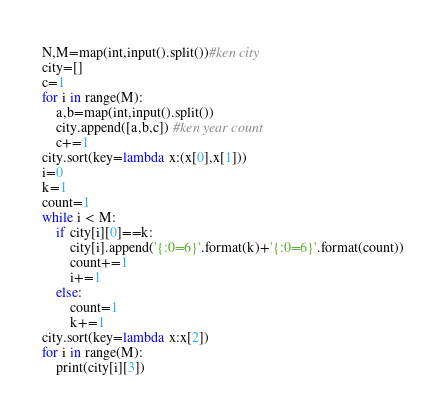Convert code to text. <code><loc_0><loc_0><loc_500><loc_500><_Python_>N,M=map(int,input().split())#ken city
city=[]
c=1
for i in range(M):
    a,b=map(int,input().split())
    city.append([a,b,c]) #ken year count
    c+=1
city.sort(key=lambda x:(x[0],x[1]))
i=0
k=1
count=1
while i < M:
    if city[i][0]==k:
        city[i].append('{:0=6}'.format(k)+'{:0=6}'.format(count))
        count+=1
        i+=1
    else:
        count=1
        k+=1
city.sort(key=lambda x:x[2])
for i in range(M):
    print(city[i][3])</code> 